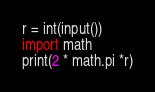<code> <loc_0><loc_0><loc_500><loc_500><_Python_>r = int(input())
import math
print(2 * math.pi *r)
</code> 